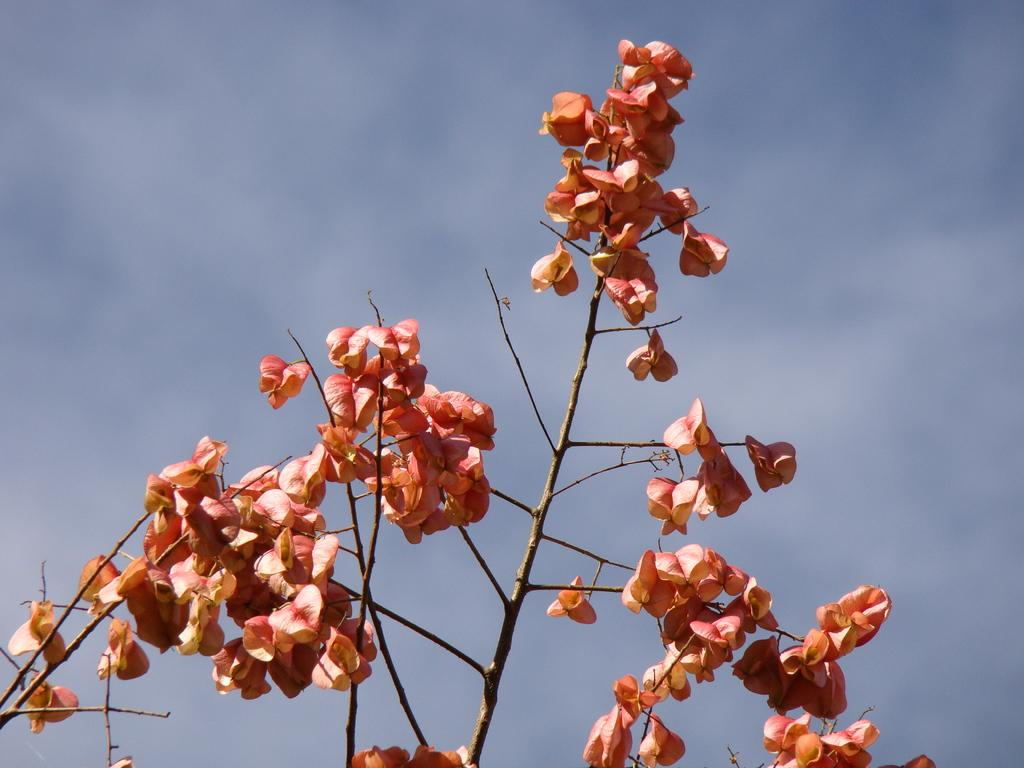What type of plant is present in the image? There are flowers on a plant in the image. What can be seen in the background of the image? The sky is visible in the background of the image. How would you describe the sky in the image? The sky appears to be cloudy. How many yams are being transported by the trucks in the image? There are no trucks or yams present in the image. What type of ring is visible on the plant in the image? There is no ring present on the plant in the image; it only has flowers. 